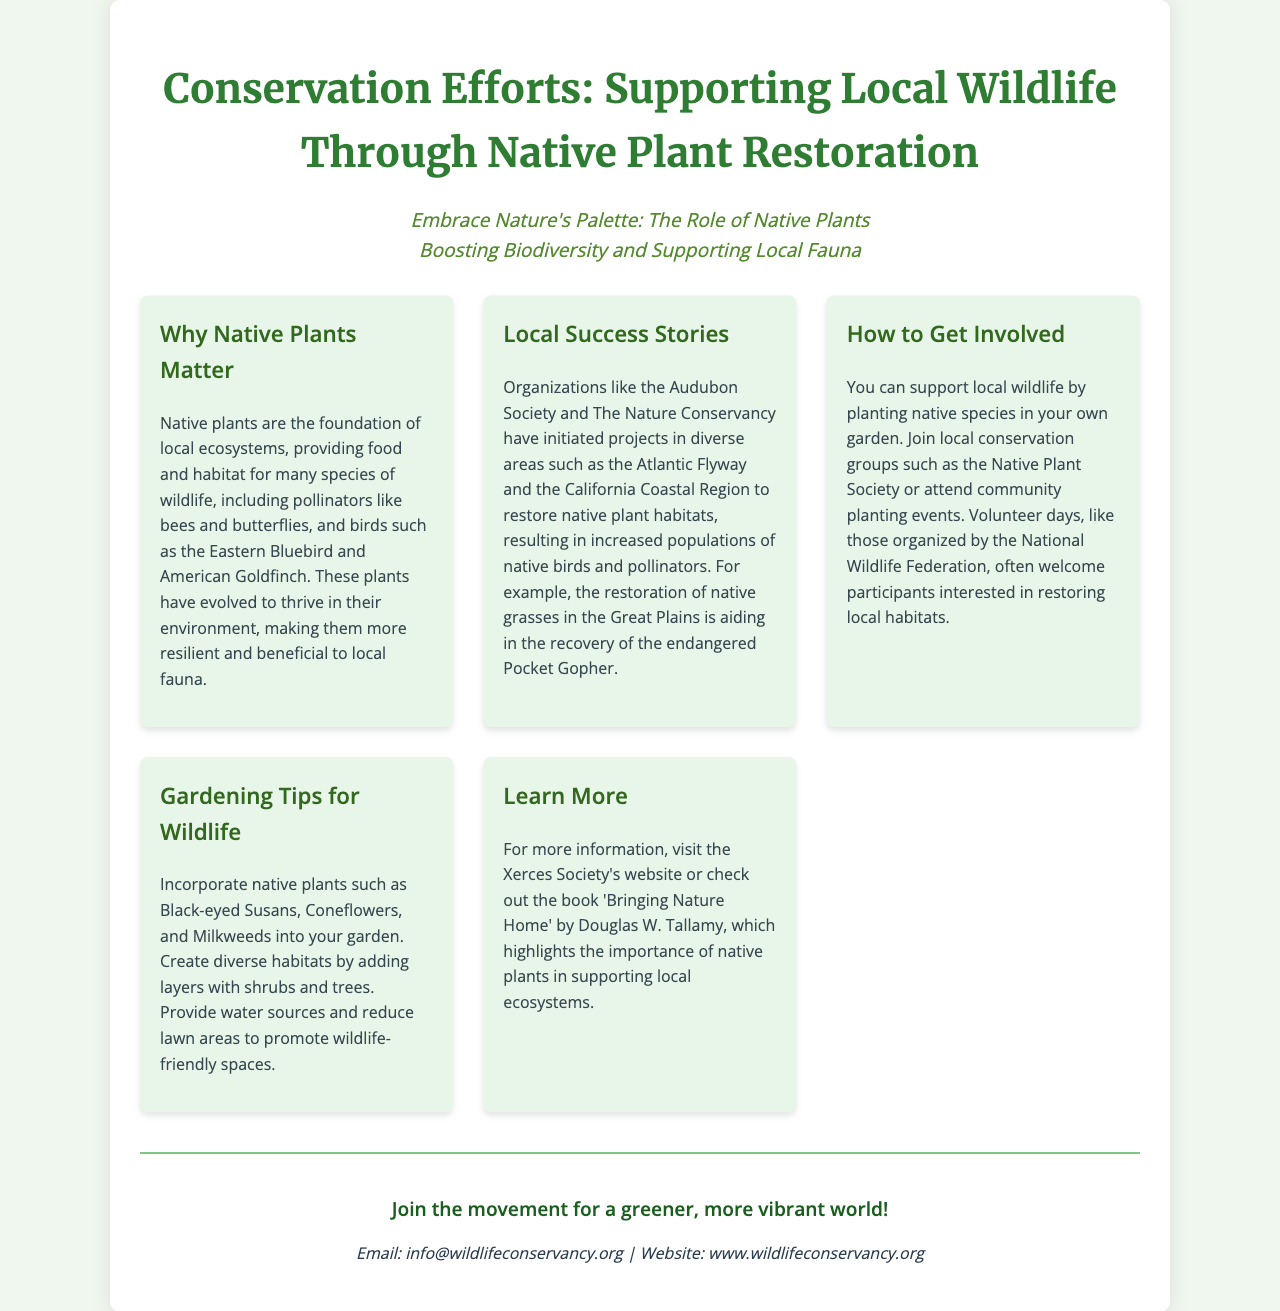What is the main purpose of native plants? The document states that native plants provide food and habitat for many species of wildlife.
Answer: Food and habitat for wildlife Which organizations are mentioned for their work in native plant restoration? The document lists the Audubon Society and The Nature Conservancy as organizations involved in native plant projects.
Answer: Audubon Society and The Nature Conservancy What plant is suggested for wildlife gardening? The document recommends including Black-eyed Susans in wildlife gardens.
Answer: Black-eyed Susans What region is mentioned regarding the restoration of native grasses? The Great Plains is mentioned in relation to the restoration of native grasses.
Answer: Great Plains How can individuals support local wildlife according to the brochure? The brochure suggests planting native species in gardens as a way to support local wildlife.
Answer: Planting native species What is the contact email provided for more information? The document shows an email for inquiries related to wildlife conservation efforts.
Answer: info@wildlifeconservancy.org What type of events are organized by the National Wildlife Federation? The document states that volunteer days are organized by the National Wildlife Federation.
Answer: Volunteer days Which book is recommended for learning more about native plants? The brochure recommends the book 'Bringing Nature Home' by Douglas W. Tallamy.
Answer: 'Bringing Nature Home' 